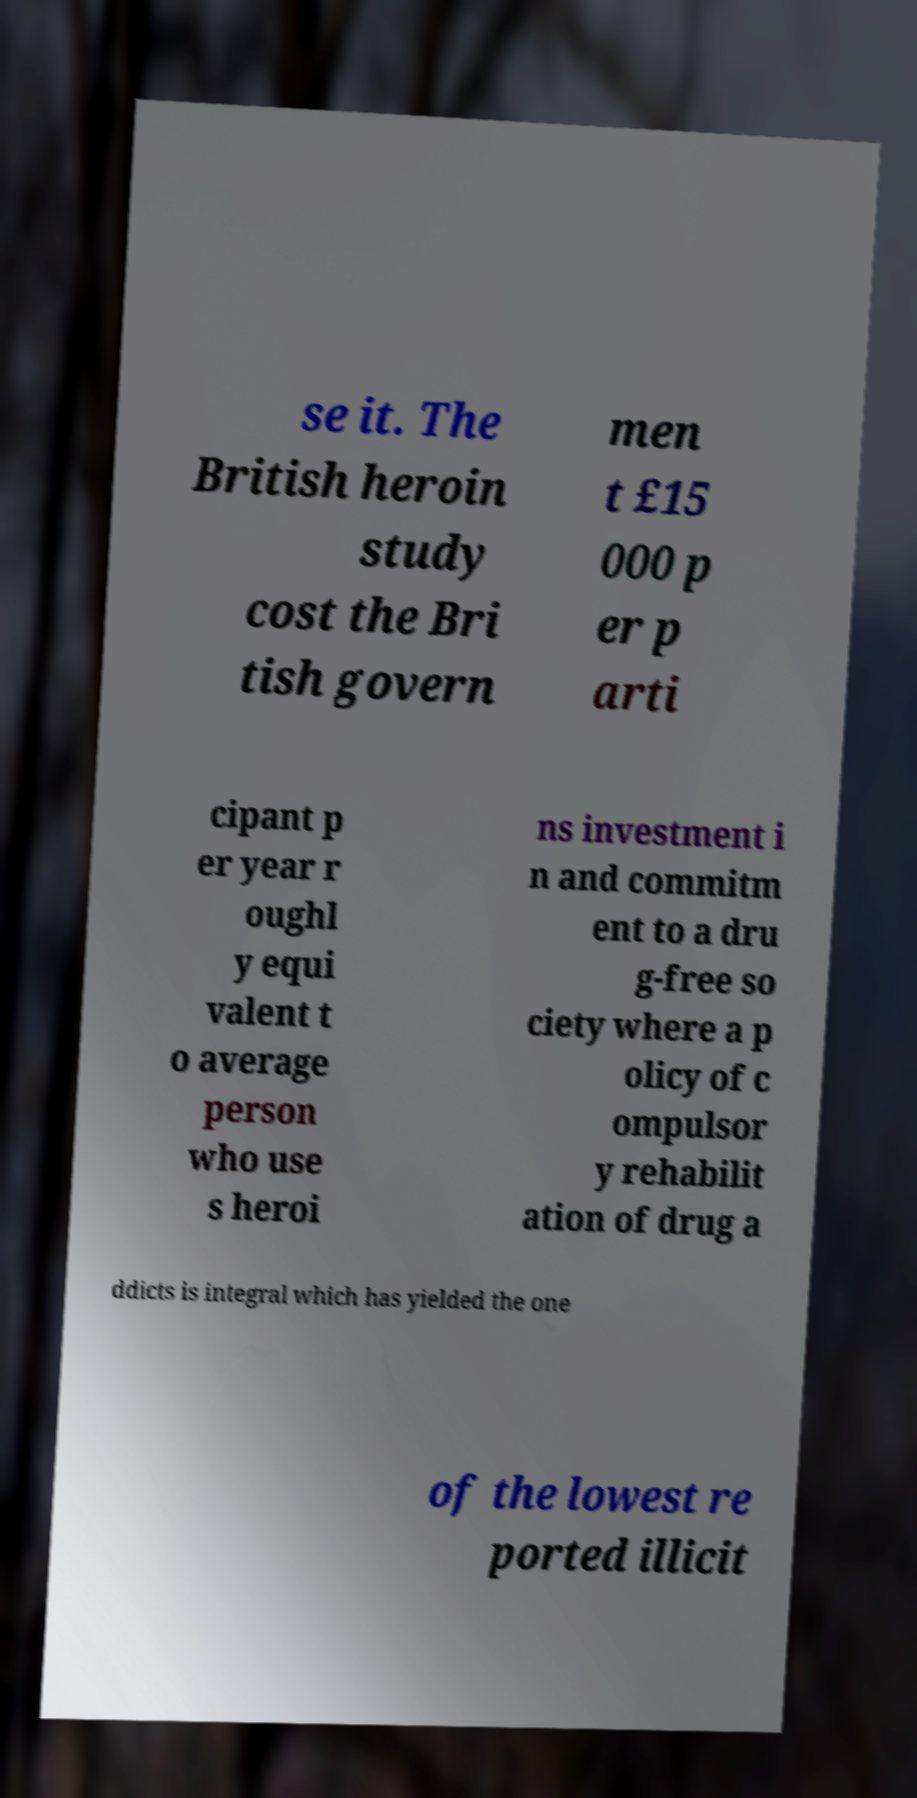Can you read and provide the text displayed in the image?This photo seems to have some interesting text. Can you extract and type it out for me? se it. The British heroin study cost the Bri tish govern men t £15 000 p er p arti cipant p er year r oughl y equi valent t o average person who use s heroi ns investment i n and commitm ent to a dru g-free so ciety where a p olicy of c ompulsor y rehabilit ation of drug a ddicts is integral which has yielded the one of the lowest re ported illicit 